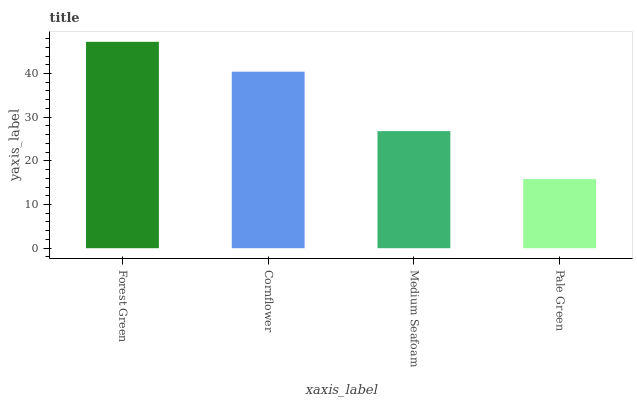Is Cornflower the minimum?
Answer yes or no. No. Is Cornflower the maximum?
Answer yes or no. No. Is Forest Green greater than Cornflower?
Answer yes or no. Yes. Is Cornflower less than Forest Green?
Answer yes or no. Yes. Is Cornflower greater than Forest Green?
Answer yes or no. No. Is Forest Green less than Cornflower?
Answer yes or no. No. Is Cornflower the high median?
Answer yes or no. Yes. Is Medium Seafoam the low median?
Answer yes or no. Yes. Is Medium Seafoam the high median?
Answer yes or no. No. Is Pale Green the low median?
Answer yes or no. No. 